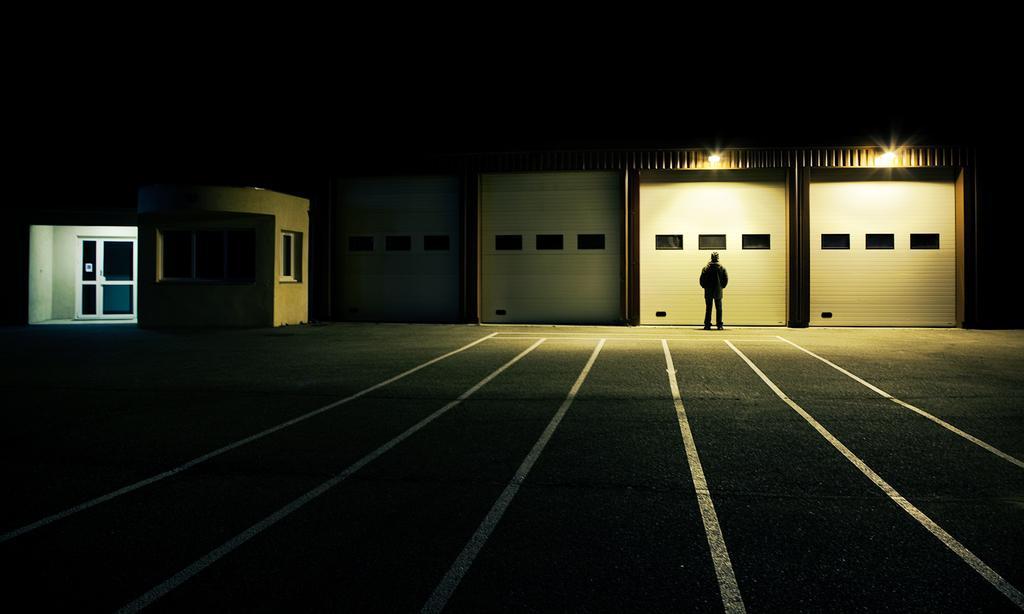Could you give a brief overview of what you see in this image? In the picture we can see a path to it, we can see some white color lines and some far away from it, we can see some house construction with a door and glass to it and besides, we can see walls with windows and in front of it we can see a man standing and we can see two lights on it. 